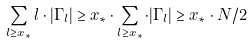Convert formula to latex. <formula><loc_0><loc_0><loc_500><loc_500>\sum _ { l \geq x _ { * } } l \cdot | \Gamma _ { l } | \geq x _ { * } \cdot \sum _ { l \geq x _ { * } } \cdot | \Gamma _ { l } | \geq x _ { * } \cdot N / 2</formula> 